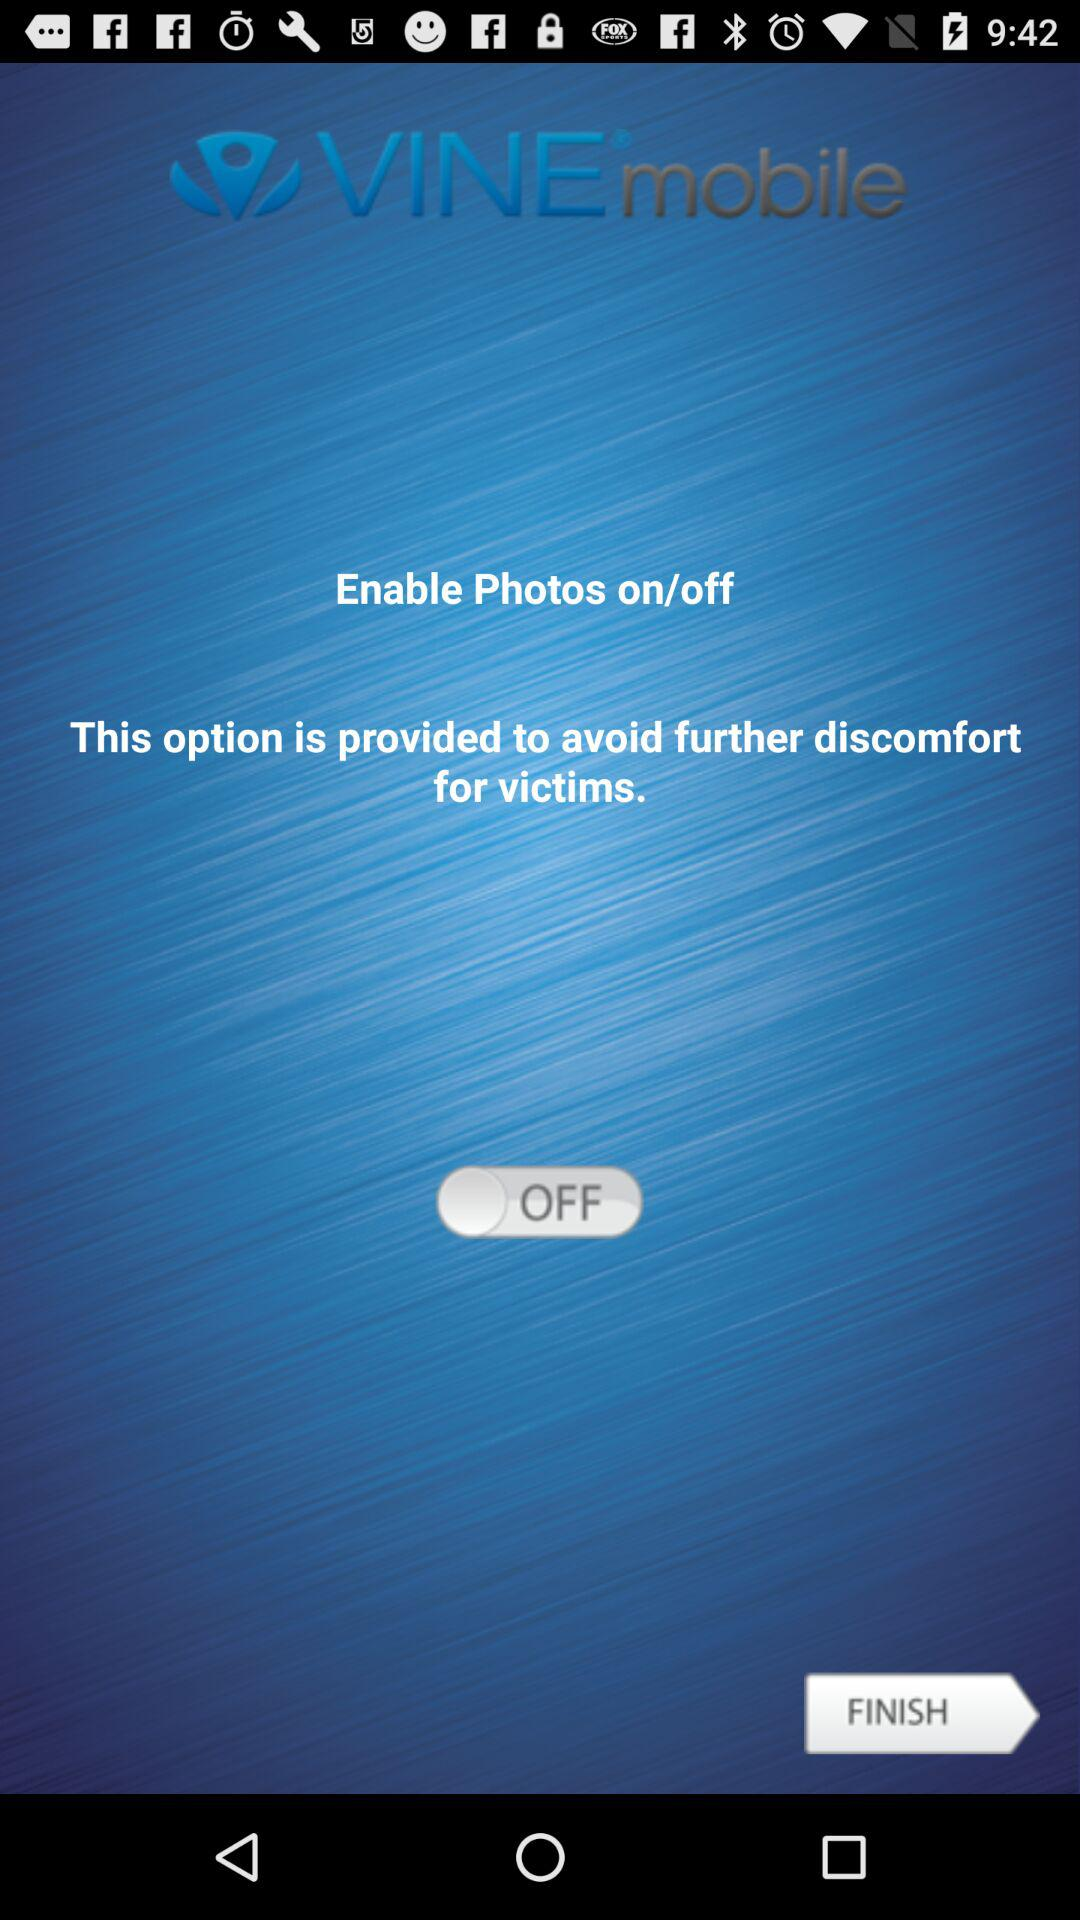What is the status of "Enable Photos"? The status is "off". 